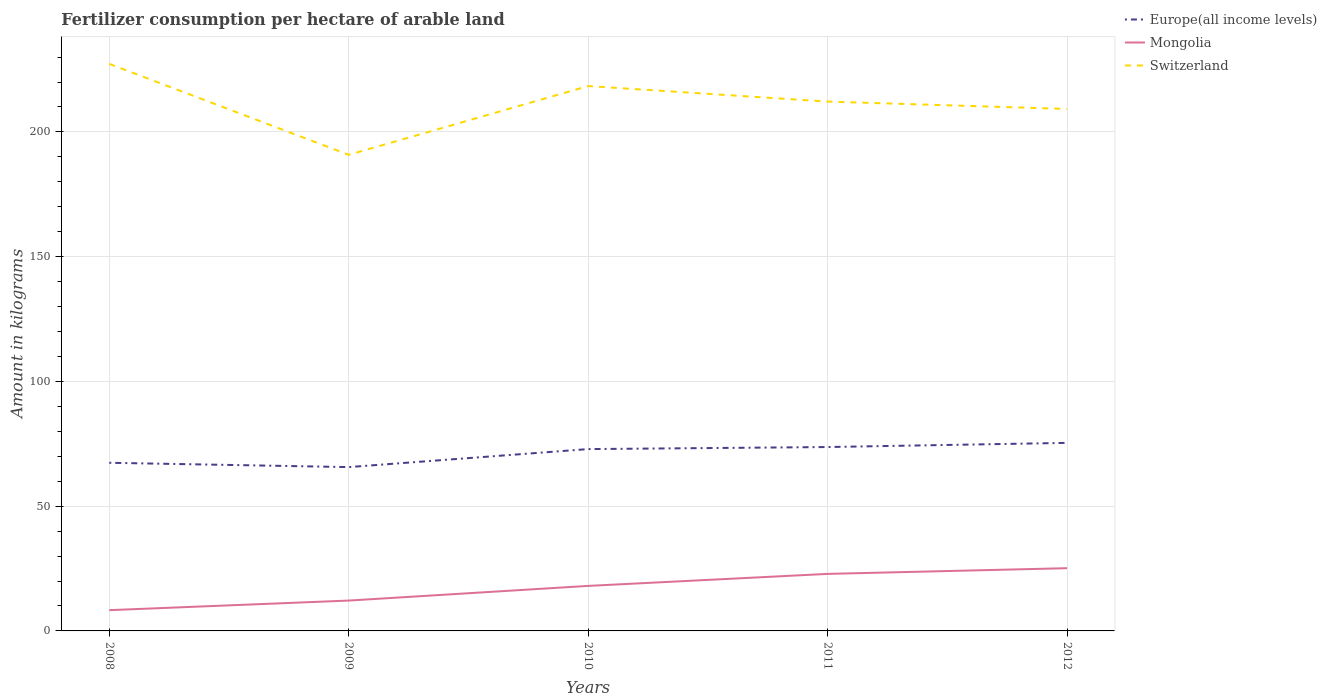How many different coloured lines are there?
Offer a very short reply. 3. Does the line corresponding to Mongolia intersect with the line corresponding to Europe(all income levels)?
Your answer should be compact. No. Across all years, what is the maximum amount of fertilizer consumption in Europe(all income levels)?
Give a very brief answer. 65.66. In which year was the amount of fertilizer consumption in Mongolia maximum?
Provide a succinct answer. 2008. What is the total amount of fertilizer consumption in Europe(all income levels) in the graph?
Offer a very short reply. 1.73. What is the difference between the highest and the second highest amount of fertilizer consumption in Mongolia?
Make the answer very short. 16.82. Does the graph contain grids?
Offer a terse response. Yes. What is the title of the graph?
Your answer should be compact. Fertilizer consumption per hectare of arable land. Does "Lower middle income" appear as one of the legend labels in the graph?
Your answer should be compact. No. What is the label or title of the X-axis?
Your answer should be very brief. Years. What is the label or title of the Y-axis?
Your answer should be compact. Amount in kilograms. What is the Amount in kilograms of Europe(all income levels) in 2008?
Give a very brief answer. 67.39. What is the Amount in kilograms in Mongolia in 2008?
Your answer should be compact. 8.32. What is the Amount in kilograms in Switzerland in 2008?
Keep it short and to the point. 227.27. What is the Amount in kilograms of Europe(all income levels) in 2009?
Give a very brief answer. 65.66. What is the Amount in kilograms of Mongolia in 2009?
Your answer should be very brief. 12.17. What is the Amount in kilograms in Switzerland in 2009?
Your response must be concise. 190.83. What is the Amount in kilograms in Europe(all income levels) in 2010?
Your answer should be compact. 72.88. What is the Amount in kilograms of Mongolia in 2010?
Make the answer very short. 18.05. What is the Amount in kilograms in Switzerland in 2010?
Keep it short and to the point. 218.38. What is the Amount in kilograms in Europe(all income levels) in 2011?
Ensure brevity in your answer.  73.7. What is the Amount in kilograms of Mongolia in 2011?
Provide a succinct answer. 22.86. What is the Amount in kilograms of Switzerland in 2011?
Offer a terse response. 212.16. What is the Amount in kilograms of Europe(all income levels) in 2012?
Make the answer very short. 75.37. What is the Amount in kilograms of Mongolia in 2012?
Provide a succinct answer. 25.14. What is the Amount in kilograms of Switzerland in 2012?
Ensure brevity in your answer.  209.21. Across all years, what is the maximum Amount in kilograms of Europe(all income levels)?
Make the answer very short. 75.37. Across all years, what is the maximum Amount in kilograms of Mongolia?
Offer a very short reply. 25.14. Across all years, what is the maximum Amount in kilograms in Switzerland?
Your answer should be compact. 227.27. Across all years, what is the minimum Amount in kilograms in Europe(all income levels)?
Provide a succinct answer. 65.66. Across all years, what is the minimum Amount in kilograms of Mongolia?
Ensure brevity in your answer.  8.32. Across all years, what is the minimum Amount in kilograms of Switzerland?
Offer a very short reply. 190.83. What is the total Amount in kilograms of Europe(all income levels) in the graph?
Make the answer very short. 355.01. What is the total Amount in kilograms of Mongolia in the graph?
Provide a short and direct response. 86.54. What is the total Amount in kilograms in Switzerland in the graph?
Keep it short and to the point. 1057.86. What is the difference between the Amount in kilograms of Europe(all income levels) in 2008 and that in 2009?
Provide a succinct answer. 1.73. What is the difference between the Amount in kilograms of Mongolia in 2008 and that in 2009?
Your answer should be compact. -3.85. What is the difference between the Amount in kilograms of Switzerland in 2008 and that in 2009?
Your answer should be compact. 36.44. What is the difference between the Amount in kilograms of Europe(all income levels) in 2008 and that in 2010?
Your answer should be compact. -5.49. What is the difference between the Amount in kilograms of Mongolia in 2008 and that in 2010?
Keep it short and to the point. -9.72. What is the difference between the Amount in kilograms of Switzerland in 2008 and that in 2010?
Your response must be concise. 8.89. What is the difference between the Amount in kilograms in Europe(all income levels) in 2008 and that in 2011?
Offer a terse response. -6.31. What is the difference between the Amount in kilograms of Mongolia in 2008 and that in 2011?
Your answer should be very brief. -14.53. What is the difference between the Amount in kilograms of Switzerland in 2008 and that in 2011?
Provide a short and direct response. 15.11. What is the difference between the Amount in kilograms in Europe(all income levels) in 2008 and that in 2012?
Give a very brief answer. -7.98. What is the difference between the Amount in kilograms of Mongolia in 2008 and that in 2012?
Make the answer very short. -16.82. What is the difference between the Amount in kilograms of Switzerland in 2008 and that in 2012?
Provide a succinct answer. 18.07. What is the difference between the Amount in kilograms in Europe(all income levels) in 2009 and that in 2010?
Provide a succinct answer. -7.22. What is the difference between the Amount in kilograms in Mongolia in 2009 and that in 2010?
Offer a terse response. -5.88. What is the difference between the Amount in kilograms of Switzerland in 2009 and that in 2010?
Provide a succinct answer. -27.55. What is the difference between the Amount in kilograms of Europe(all income levels) in 2009 and that in 2011?
Keep it short and to the point. -8.04. What is the difference between the Amount in kilograms in Mongolia in 2009 and that in 2011?
Ensure brevity in your answer.  -10.69. What is the difference between the Amount in kilograms in Switzerland in 2009 and that in 2011?
Provide a succinct answer. -21.33. What is the difference between the Amount in kilograms in Europe(all income levels) in 2009 and that in 2012?
Provide a succinct answer. -9.71. What is the difference between the Amount in kilograms in Mongolia in 2009 and that in 2012?
Make the answer very short. -12.97. What is the difference between the Amount in kilograms of Switzerland in 2009 and that in 2012?
Offer a terse response. -18.38. What is the difference between the Amount in kilograms of Europe(all income levels) in 2010 and that in 2011?
Your response must be concise. -0.82. What is the difference between the Amount in kilograms of Mongolia in 2010 and that in 2011?
Ensure brevity in your answer.  -4.81. What is the difference between the Amount in kilograms of Switzerland in 2010 and that in 2011?
Provide a short and direct response. 6.22. What is the difference between the Amount in kilograms of Europe(all income levels) in 2010 and that in 2012?
Provide a short and direct response. -2.49. What is the difference between the Amount in kilograms in Mongolia in 2010 and that in 2012?
Your response must be concise. -7.1. What is the difference between the Amount in kilograms in Switzerland in 2010 and that in 2012?
Your answer should be very brief. 9.18. What is the difference between the Amount in kilograms of Europe(all income levels) in 2011 and that in 2012?
Your answer should be compact. -1.67. What is the difference between the Amount in kilograms of Mongolia in 2011 and that in 2012?
Make the answer very short. -2.29. What is the difference between the Amount in kilograms of Switzerland in 2011 and that in 2012?
Ensure brevity in your answer.  2.96. What is the difference between the Amount in kilograms in Europe(all income levels) in 2008 and the Amount in kilograms in Mongolia in 2009?
Offer a terse response. 55.22. What is the difference between the Amount in kilograms in Europe(all income levels) in 2008 and the Amount in kilograms in Switzerland in 2009?
Give a very brief answer. -123.44. What is the difference between the Amount in kilograms of Mongolia in 2008 and the Amount in kilograms of Switzerland in 2009?
Offer a terse response. -182.51. What is the difference between the Amount in kilograms in Europe(all income levels) in 2008 and the Amount in kilograms in Mongolia in 2010?
Provide a short and direct response. 49.35. What is the difference between the Amount in kilograms of Europe(all income levels) in 2008 and the Amount in kilograms of Switzerland in 2010?
Provide a succinct answer. -150.99. What is the difference between the Amount in kilograms in Mongolia in 2008 and the Amount in kilograms in Switzerland in 2010?
Your answer should be compact. -210.06. What is the difference between the Amount in kilograms in Europe(all income levels) in 2008 and the Amount in kilograms in Mongolia in 2011?
Your answer should be compact. 44.54. What is the difference between the Amount in kilograms of Europe(all income levels) in 2008 and the Amount in kilograms of Switzerland in 2011?
Provide a succinct answer. -144.77. What is the difference between the Amount in kilograms of Mongolia in 2008 and the Amount in kilograms of Switzerland in 2011?
Your answer should be compact. -203.84. What is the difference between the Amount in kilograms of Europe(all income levels) in 2008 and the Amount in kilograms of Mongolia in 2012?
Provide a short and direct response. 42.25. What is the difference between the Amount in kilograms of Europe(all income levels) in 2008 and the Amount in kilograms of Switzerland in 2012?
Provide a short and direct response. -141.81. What is the difference between the Amount in kilograms in Mongolia in 2008 and the Amount in kilograms in Switzerland in 2012?
Ensure brevity in your answer.  -200.88. What is the difference between the Amount in kilograms of Europe(all income levels) in 2009 and the Amount in kilograms of Mongolia in 2010?
Offer a very short reply. 47.62. What is the difference between the Amount in kilograms in Europe(all income levels) in 2009 and the Amount in kilograms in Switzerland in 2010?
Make the answer very short. -152.72. What is the difference between the Amount in kilograms in Mongolia in 2009 and the Amount in kilograms in Switzerland in 2010?
Offer a terse response. -206.21. What is the difference between the Amount in kilograms of Europe(all income levels) in 2009 and the Amount in kilograms of Mongolia in 2011?
Make the answer very short. 42.81. What is the difference between the Amount in kilograms of Europe(all income levels) in 2009 and the Amount in kilograms of Switzerland in 2011?
Give a very brief answer. -146.5. What is the difference between the Amount in kilograms in Mongolia in 2009 and the Amount in kilograms in Switzerland in 2011?
Your answer should be compact. -199.99. What is the difference between the Amount in kilograms in Europe(all income levels) in 2009 and the Amount in kilograms in Mongolia in 2012?
Your response must be concise. 40.52. What is the difference between the Amount in kilograms of Europe(all income levels) in 2009 and the Amount in kilograms of Switzerland in 2012?
Offer a very short reply. -143.54. What is the difference between the Amount in kilograms in Mongolia in 2009 and the Amount in kilograms in Switzerland in 2012?
Keep it short and to the point. -197.04. What is the difference between the Amount in kilograms in Europe(all income levels) in 2010 and the Amount in kilograms in Mongolia in 2011?
Provide a short and direct response. 50.03. What is the difference between the Amount in kilograms of Europe(all income levels) in 2010 and the Amount in kilograms of Switzerland in 2011?
Provide a succinct answer. -139.28. What is the difference between the Amount in kilograms in Mongolia in 2010 and the Amount in kilograms in Switzerland in 2011?
Offer a terse response. -194.12. What is the difference between the Amount in kilograms of Europe(all income levels) in 2010 and the Amount in kilograms of Mongolia in 2012?
Offer a very short reply. 47.74. What is the difference between the Amount in kilograms in Europe(all income levels) in 2010 and the Amount in kilograms in Switzerland in 2012?
Give a very brief answer. -136.33. What is the difference between the Amount in kilograms in Mongolia in 2010 and the Amount in kilograms in Switzerland in 2012?
Your response must be concise. -191.16. What is the difference between the Amount in kilograms in Europe(all income levels) in 2011 and the Amount in kilograms in Mongolia in 2012?
Your answer should be very brief. 48.56. What is the difference between the Amount in kilograms in Europe(all income levels) in 2011 and the Amount in kilograms in Switzerland in 2012?
Offer a very short reply. -135.5. What is the difference between the Amount in kilograms in Mongolia in 2011 and the Amount in kilograms in Switzerland in 2012?
Provide a succinct answer. -186.35. What is the average Amount in kilograms of Europe(all income levels) per year?
Your response must be concise. 71. What is the average Amount in kilograms of Mongolia per year?
Your answer should be very brief. 17.31. What is the average Amount in kilograms in Switzerland per year?
Your answer should be compact. 211.57. In the year 2008, what is the difference between the Amount in kilograms in Europe(all income levels) and Amount in kilograms in Mongolia?
Provide a succinct answer. 59.07. In the year 2008, what is the difference between the Amount in kilograms of Europe(all income levels) and Amount in kilograms of Switzerland?
Your answer should be very brief. -159.88. In the year 2008, what is the difference between the Amount in kilograms in Mongolia and Amount in kilograms in Switzerland?
Make the answer very short. -218.95. In the year 2009, what is the difference between the Amount in kilograms of Europe(all income levels) and Amount in kilograms of Mongolia?
Your response must be concise. 53.49. In the year 2009, what is the difference between the Amount in kilograms in Europe(all income levels) and Amount in kilograms in Switzerland?
Give a very brief answer. -125.17. In the year 2009, what is the difference between the Amount in kilograms in Mongolia and Amount in kilograms in Switzerland?
Give a very brief answer. -178.66. In the year 2010, what is the difference between the Amount in kilograms in Europe(all income levels) and Amount in kilograms in Mongolia?
Your answer should be very brief. 54.84. In the year 2010, what is the difference between the Amount in kilograms of Europe(all income levels) and Amount in kilograms of Switzerland?
Keep it short and to the point. -145.5. In the year 2010, what is the difference between the Amount in kilograms in Mongolia and Amount in kilograms in Switzerland?
Provide a short and direct response. -200.34. In the year 2011, what is the difference between the Amount in kilograms of Europe(all income levels) and Amount in kilograms of Mongolia?
Provide a short and direct response. 50.85. In the year 2011, what is the difference between the Amount in kilograms of Europe(all income levels) and Amount in kilograms of Switzerland?
Make the answer very short. -138.46. In the year 2011, what is the difference between the Amount in kilograms in Mongolia and Amount in kilograms in Switzerland?
Your answer should be very brief. -189.31. In the year 2012, what is the difference between the Amount in kilograms of Europe(all income levels) and Amount in kilograms of Mongolia?
Ensure brevity in your answer.  50.23. In the year 2012, what is the difference between the Amount in kilograms in Europe(all income levels) and Amount in kilograms in Switzerland?
Provide a short and direct response. -133.83. In the year 2012, what is the difference between the Amount in kilograms of Mongolia and Amount in kilograms of Switzerland?
Offer a terse response. -184.07. What is the ratio of the Amount in kilograms of Europe(all income levels) in 2008 to that in 2009?
Offer a terse response. 1.03. What is the ratio of the Amount in kilograms of Mongolia in 2008 to that in 2009?
Give a very brief answer. 0.68. What is the ratio of the Amount in kilograms in Switzerland in 2008 to that in 2009?
Make the answer very short. 1.19. What is the ratio of the Amount in kilograms in Europe(all income levels) in 2008 to that in 2010?
Your answer should be compact. 0.92. What is the ratio of the Amount in kilograms of Mongolia in 2008 to that in 2010?
Offer a terse response. 0.46. What is the ratio of the Amount in kilograms of Switzerland in 2008 to that in 2010?
Your response must be concise. 1.04. What is the ratio of the Amount in kilograms in Europe(all income levels) in 2008 to that in 2011?
Offer a terse response. 0.91. What is the ratio of the Amount in kilograms in Mongolia in 2008 to that in 2011?
Keep it short and to the point. 0.36. What is the ratio of the Amount in kilograms of Switzerland in 2008 to that in 2011?
Your answer should be very brief. 1.07. What is the ratio of the Amount in kilograms of Europe(all income levels) in 2008 to that in 2012?
Your response must be concise. 0.89. What is the ratio of the Amount in kilograms in Mongolia in 2008 to that in 2012?
Offer a very short reply. 0.33. What is the ratio of the Amount in kilograms of Switzerland in 2008 to that in 2012?
Your answer should be compact. 1.09. What is the ratio of the Amount in kilograms of Europe(all income levels) in 2009 to that in 2010?
Offer a terse response. 0.9. What is the ratio of the Amount in kilograms of Mongolia in 2009 to that in 2010?
Keep it short and to the point. 0.67. What is the ratio of the Amount in kilograms of Switzerland in 2009 to that in 2010?
Your response must be concise. 0.87. What is the ratio of the Amount in kilograms in Europe(all income levels) in 2009 to that in 2011?
Your answer should be very brief. 0.89. What is the ratio of the Amount in kilograms in Mongolia in 2009 to that in 2011?
Offer a terse response. 0.53. What is the ratio of the Amount in kilograms in Switzerland in 2009 to that in 2011?
Your answer should be very brief. 0.9. What is the ratio of the Amount in kilograms of Europe(all income levels) in 2009 to that in 2012?
Make the answer very short. 0.87. What is the ratio of the Amount in kilograms in Mongolia in 2009 to that in 2012?
Offer a terse response. 0.48. What is the ratio of the Amount in kilograms in Switzerland in 2009 to that in 2012?
Offer a terse response. 0.91. What is the ratio of the Amount in kilograms in Europe(all income levels) in 2010 to that in 2011?
Keep it short and to the point. 0.99. What is the ratio of the Amount in kilograms of Mongolia in 2010 to that in 2011?
Your response must be concise. 0.79. What is the ratio of the Amount in kilograms in Switzerland in 2010 to that in 2011?
Keep it short and to the point. 1.03. What is the ratio of the Amount in kilograms of Europe(all income levels) in 2010 to that in 2012?
Your answer should be compact. 0.97. What is the ratio of the Amount in kilograms of Mongolia in 2010 to that in 2012?
Provide a short and direct response. 0.72. What is the ratio of the Amount in kilograms in Switzerland in 2010 to that in 2012?
Your response must be concise. 1.04. What is the ratio of the Amount in kilograms of Europe(all income levels) in 2011 to that in 2012?
Keep it short and to the point. 0.98. What is the ratio of the Amount in kilograms of Switzerland in 2011 to that in 2012?
Ensure brevity in your answer.  1.01. What is the difference between the highest and the second highest Amount in kilograms in Europe(all income levels)?
Provide a succinct answer. 1.67. What is the difference between the highest and the second highest Amount in kilograms in Mongolia?
Give a very brief answer. 2.29. What is the difference between the highest and the second highest Amount in kilograms of Switzerland?
Keep it short and to the point. 8.89. What is the difference between the highest and the lowest Amount in kilograms of Europe(all income levels)?
Make the answer very short. 9.71. What is the difference between the highest and the lowest Amount in kilograms in Mongolia?
Your response must be concise. 16.82. What is the difference between the highest and the lowest Amount in kilograms in Switzerland?
Offer a very short reply. 36.44. 